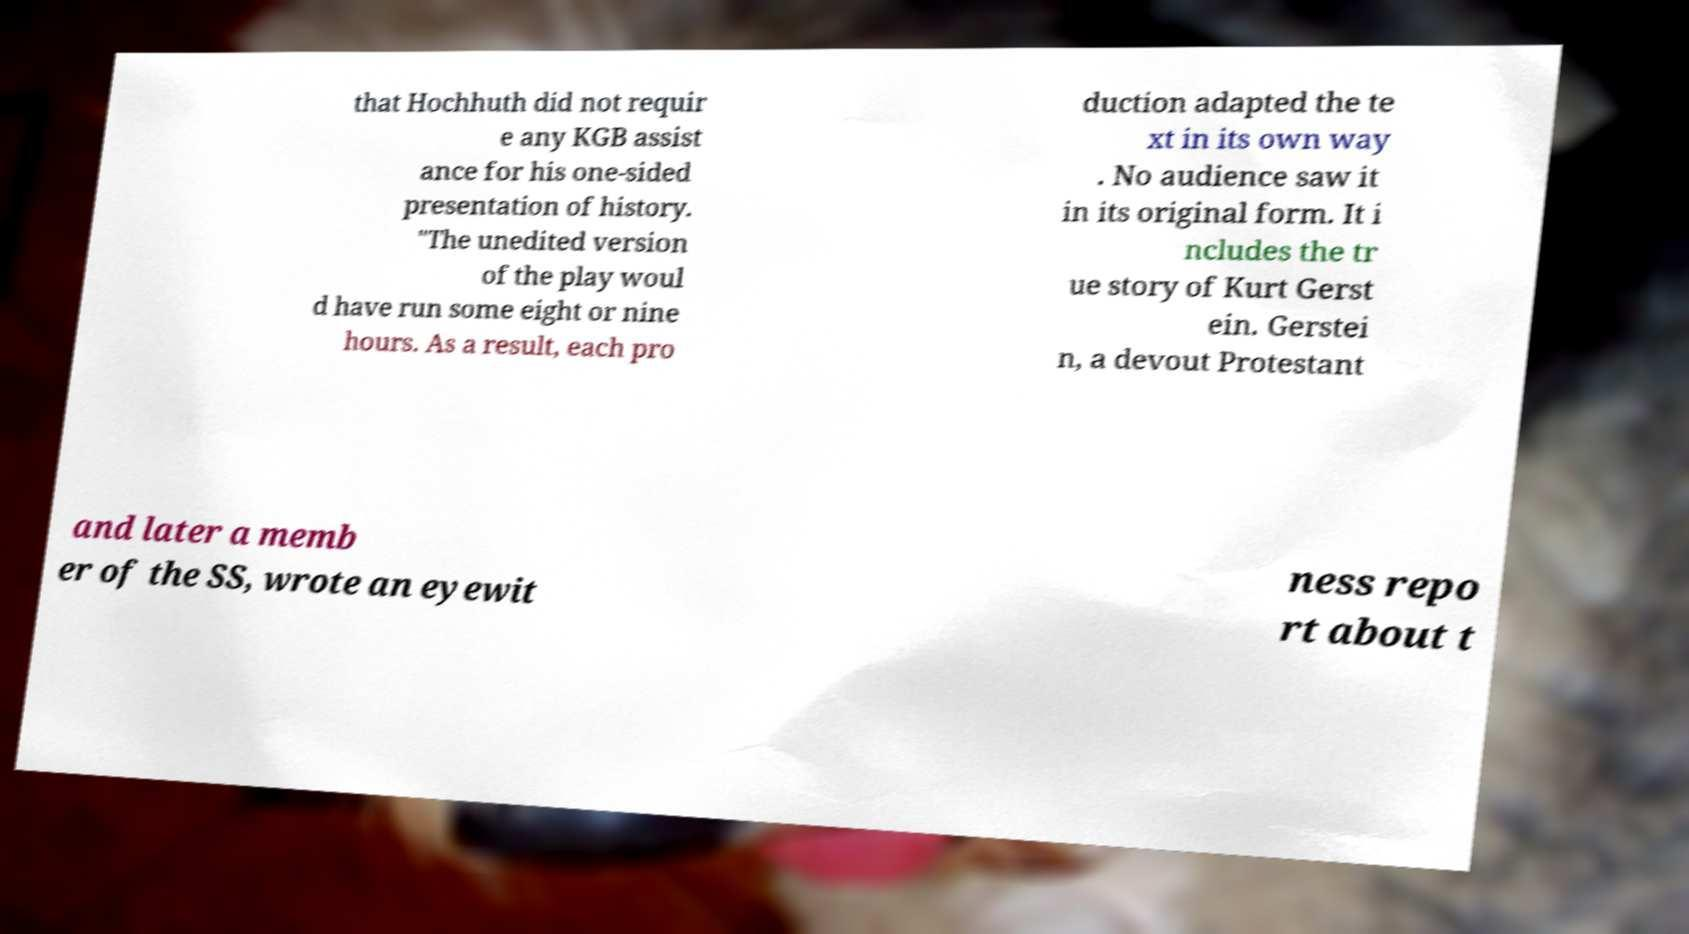Could you assist in decoding the text presented in this image and type it out clearly? that Hochhuth did not requir e any KGB assist ance for his one-sided presentation of history. "The unedited version of the play woul d have run some eight or nine hours. As a result, each pro duction adapted the te xt in its own way . No audience saw it in its original form. It i ncludes the tr ue story of Kurt Gerst ein. Gerstei n, a devout Protestant and later a memb er of the SS, wrote an eyewit ness repo rt about t 